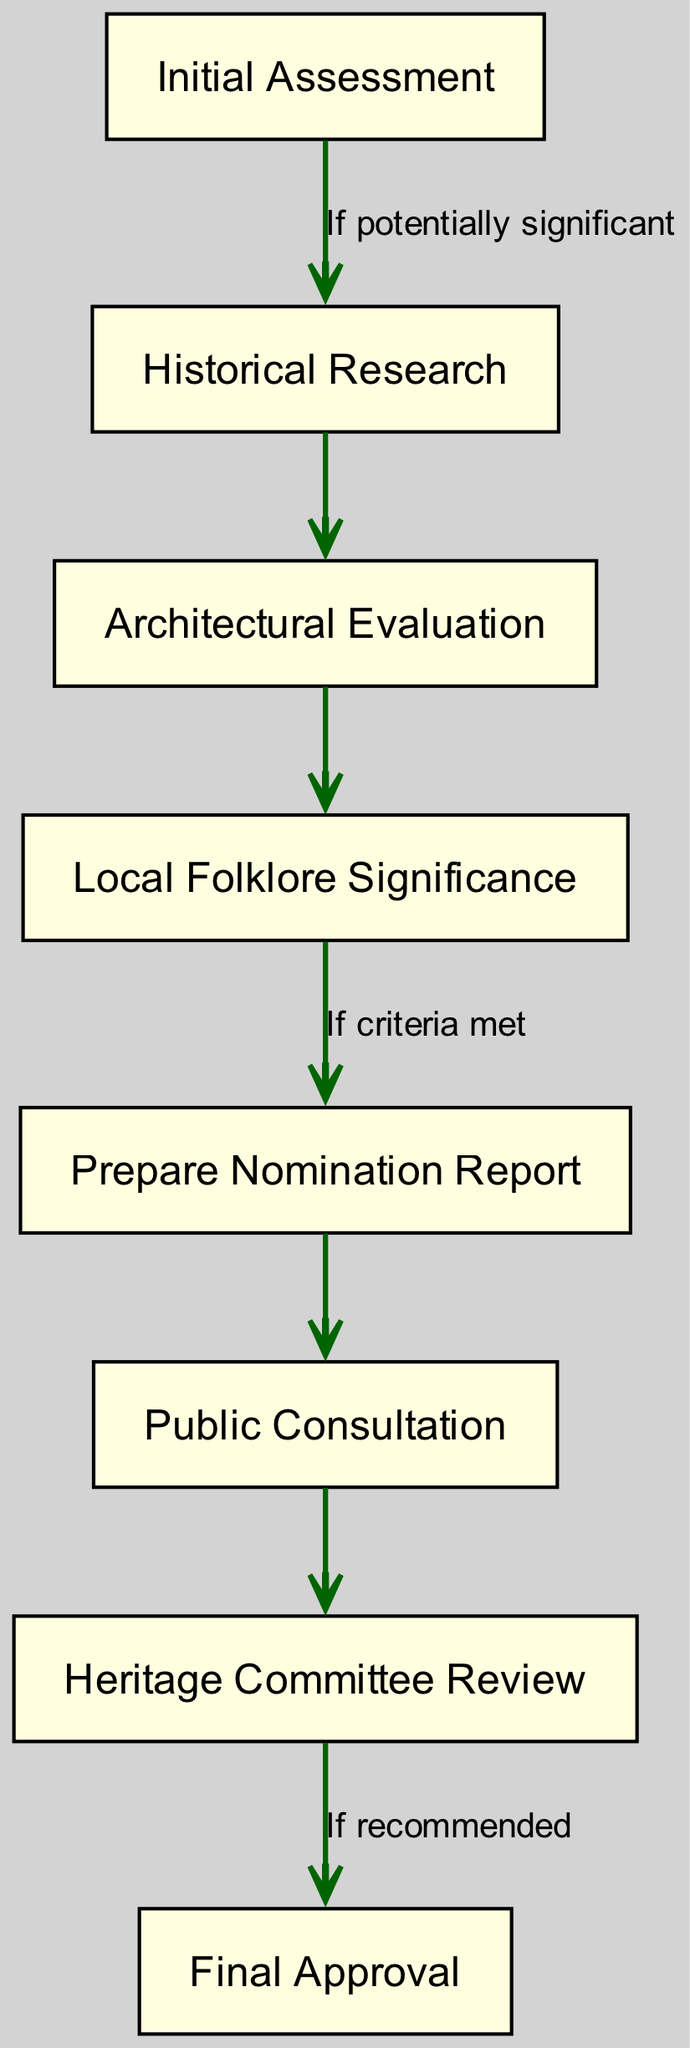What is the first step in the process? The diagram starts with the node labeled "Initial Assessment," which indicates that this is the first step in designating a building as a heritage site.
Answer: Initial Assessment How many total nodes are in the diagram? The diagram lists a total of eight nodes, which represent various steps in the designation process.
Answer: 8 Which node follows "Architectural Evaluation"? According to the flowchart, after "Architectural Evaluation," the next step is "Local Folklore Significance."
Answer: Local Folklore Significance What is the condition to move from "Local Folklore Significance" to "Prepare Nomination Report"? The flowchart indicates that you can move to "Prepare Nomination Report" if the criteria for significance are met following the "Local Folklore Significance" evaluation.
Answer: If criteria met What is the final step in the designation process? The flowchart concludes with the node labeled "Final Approval," which signifies the completion of the process after all prior steps have been completed.
Answer: Final Approval Explain the flow from "Public Consultation" to the next step. After conducting "Public Consultation," the next step in the diagram is "Heritage Committee Review," indicating that this review process follows public input before reaching a final decision.
Answer: Heritage Committee Review What must happen after "Prepare Nomination Report"? Once the "Prepare Nomination Report" is completed, the next step is "Public Consultation," suggesting that community input is sought at that stage before further evaluation.
Answer: Public Consultation What happens if the Heritage Committee recommends approval? If the Heritage Committee reviews the project and recommends it, the process flows to "Final Approval," indicating that the recommendation leads to the last stage of the designation.
Answer: Final Approval 